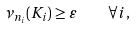<formula> <loc_0><loc_0><loc_500><loc_500>\nu _ { n _ { i } } ( K _ { i } ) \geq \varepsilon \quad \forall i ,</formula> 